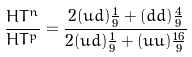Convert formula to latex. <formula><loc_0><loc_0><loc_500><loc_500>\frac { H T ^ { n } } { H T ^ { p } } = \frac { 2 ( u d ) \frac { 1 } { 9 } + ( d d ) \frac { 4 } { 9 } } { 2 ( u d ) \frac { 1 } { 9 } + ( u u ) \frac { 1 6 } { 9 } }</formula> 